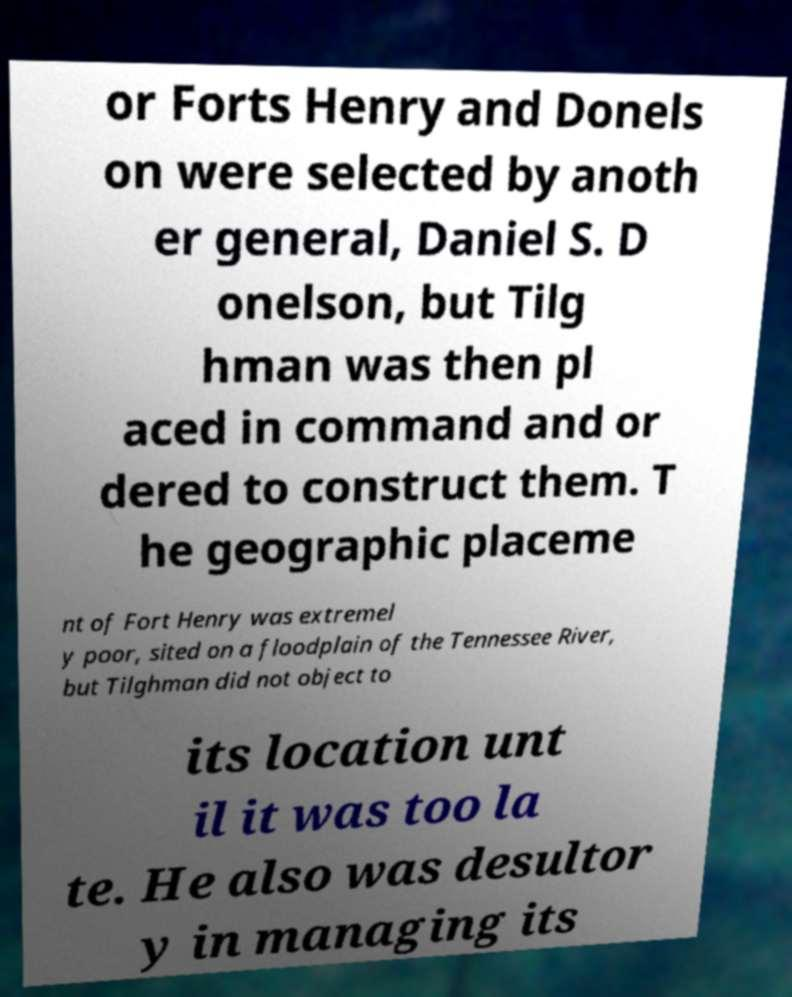I need the written content from this picture converted into text. Can you do that? or Forts Henry and Donels on were selected by anoth er general, Daniel S. D onelson, but Tilg hman was then pl aced in command and or dered to construct them. T he geographic placeme nt of Fort Henry was extremel y poor, sited on a floodplain of the Tennessee River, but Tilghman did not object to its location unt il it was too la te. He also was desultor y in managing its 